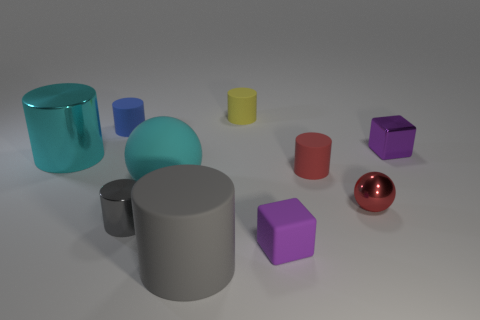Are there any balls that have the same material as the tiny red cylinder?
Ensure brevity in your answer.  Yes. The cyan metal object has what shape?
Give a very brief answer. Cylinder. What is the color of the other cylinder that is made of the same material as the small gray cylinder?
Ensure brevity in your answer.  Cyan. How many blue objects are small cylinders or small blocks?
Offer a terse response. 1. Is the number of cyan rubber balls greater than the number of small red blocks?
Make the answer very short. Yes. How many objects are tiny purple blocks right of the small red cylinder or big cylinders that are to the left of the tiny red shiny ball?
Offer a terse response. 3. What color is the rubber thing that is the same size as the cyan sphere?
Your answer should be compact. Gray. Are the big cyan cylinder and the yellow thing made of the same material?
Ensure brevity in your answer.  No. What is the material of the large cylinder that is behind the cyan object to the right of the tiny blue rubber object?
Give a very brief answer. Metal. Is the number of big shiny cylinders that are in front of the red shiny sphere greater than the number of big shiny objects?
Your answer should be very brief. No. 